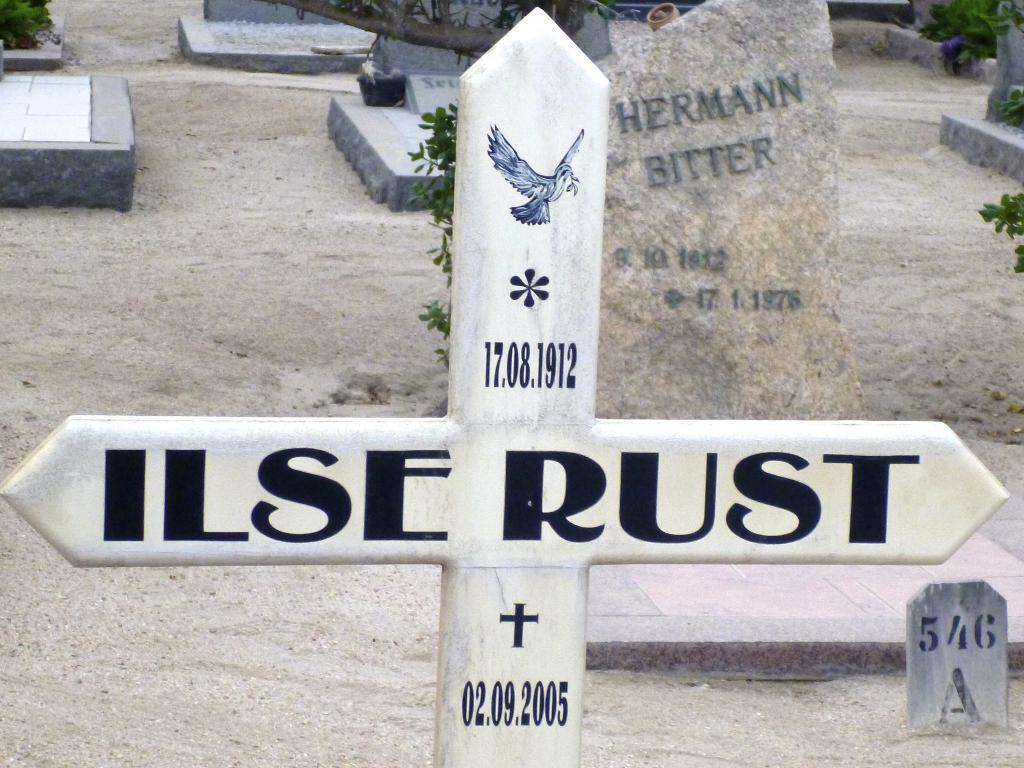Please provide a concise description of this image. In the foreground of this image, there is a cross symbol and in the background, there are few headstones and greenery on the ground. 